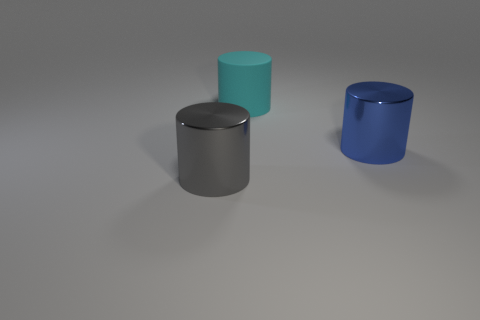Subtract all green cylinders. Subtract all purple cubes. How many cylinders are left? 3 Subtract all green spheres. How many blue cylinders are left? 1 Add 3 large things. How many big blues exist? 0 Subtract all metallic cylinders. Subtract all big gray metal things. How many objects are left? 0 Add 3 gray things. How many gray things are left? 4 Add 3 small purple cubes. How many small purple cubes exist? 3 Add 1 cyan matte things. How many objects exist? 4 Subtract all blue cylinders. How many cylinders are left? 2 Subtract all gray metal cylinders. How many cylinders are left? 2 Subtract 0 purple balls. How many objects are left? 3 